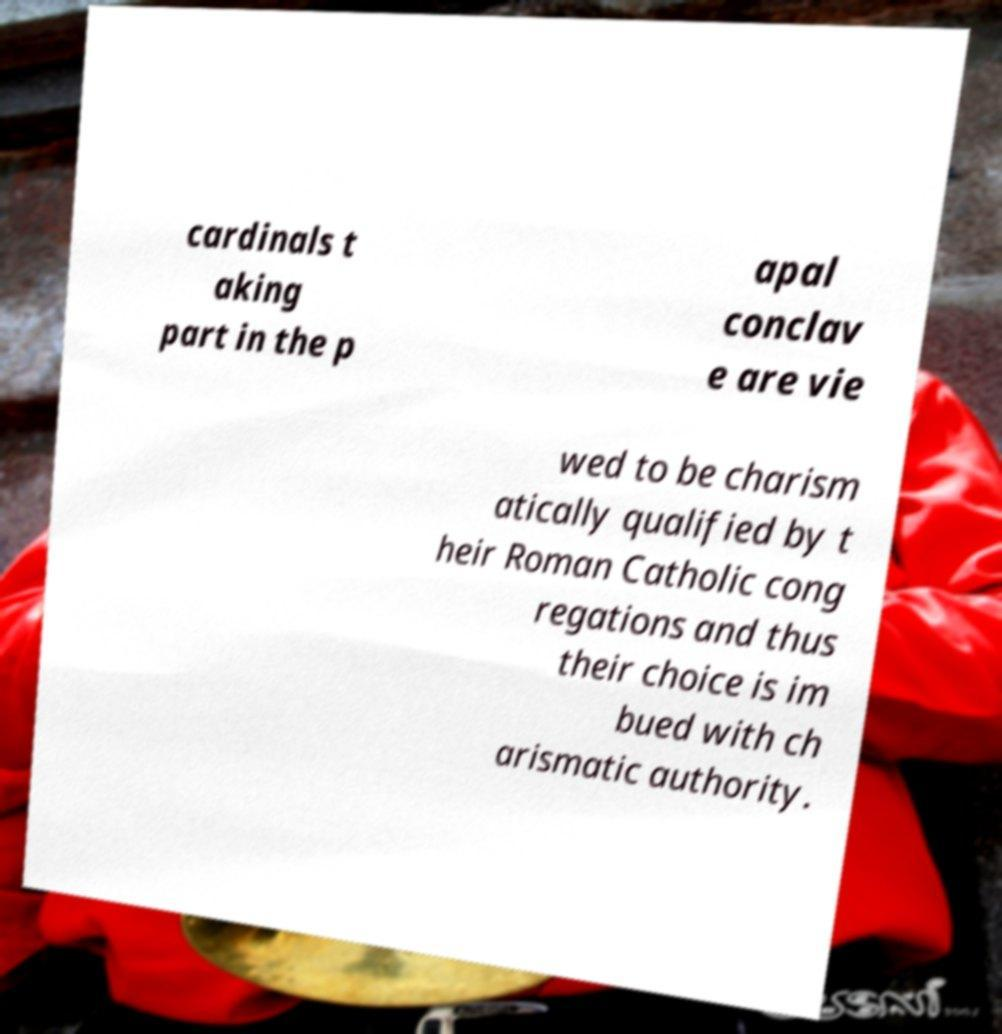There's text embedded in this image that I need extracted. Can you transcribe it verbatim? cardinals t aking part in the p apal conclav e are vie wed to be charism atically qualified by t heir Roman Catholic cong regations and thus their choice is im bued with ch arismatic authority. 